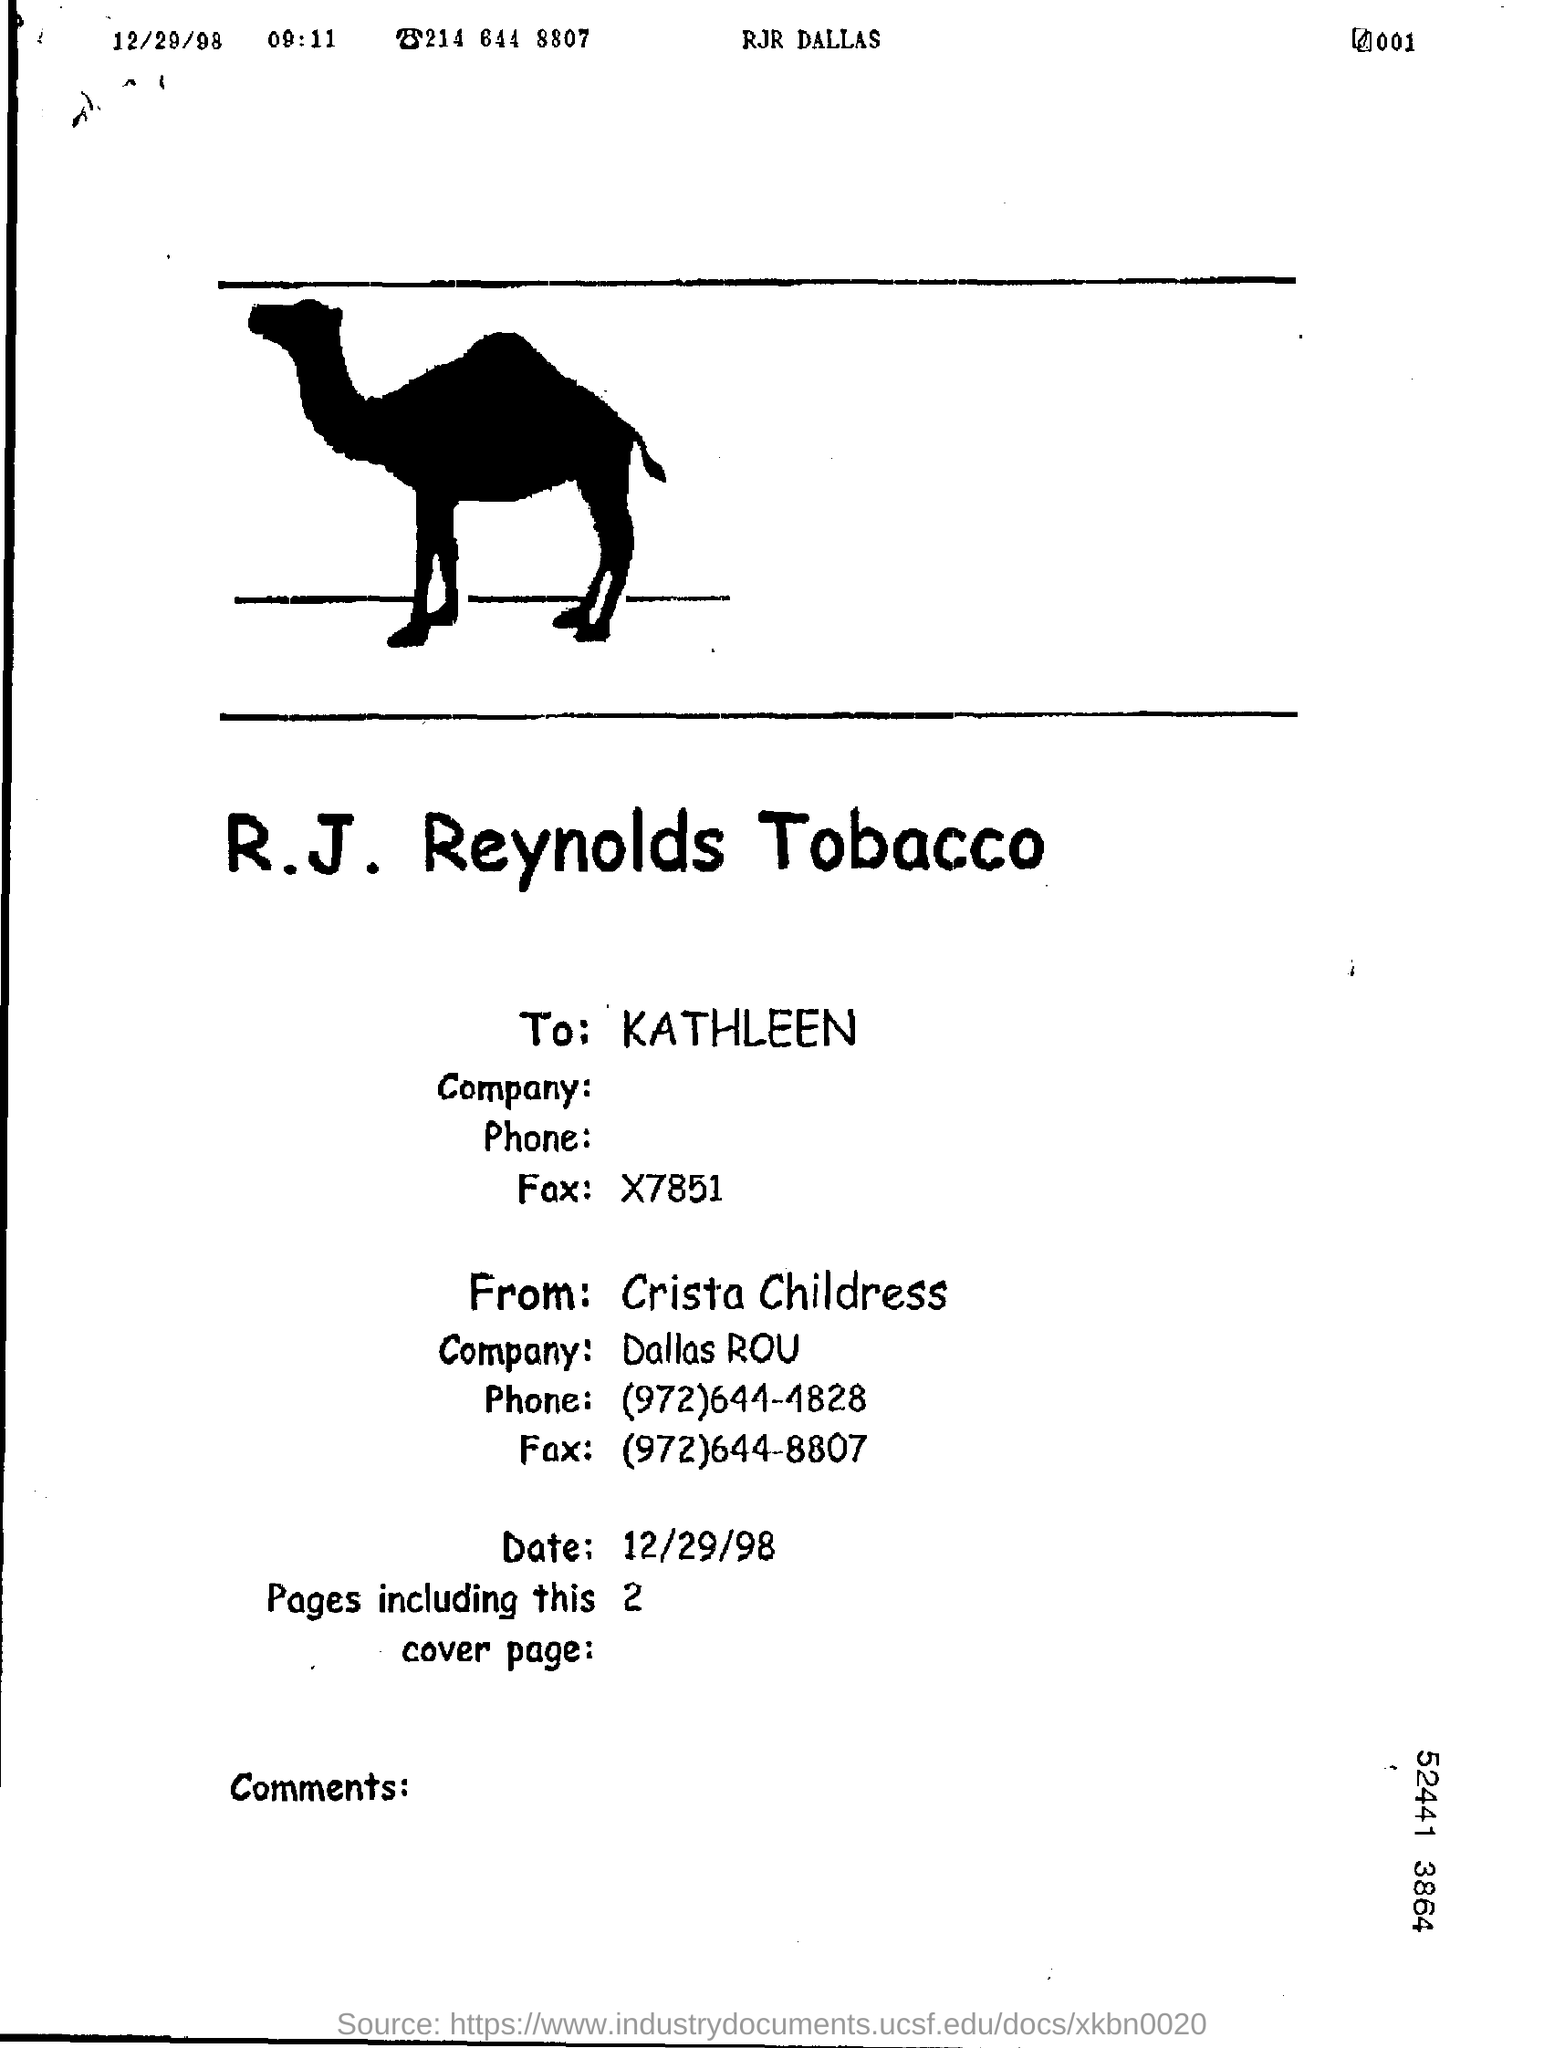To whom is this written ?
Ensure brevity in your answer.  Kathleen. Whom is this written from ?
Provide a succinct answer. Crista Childress. 